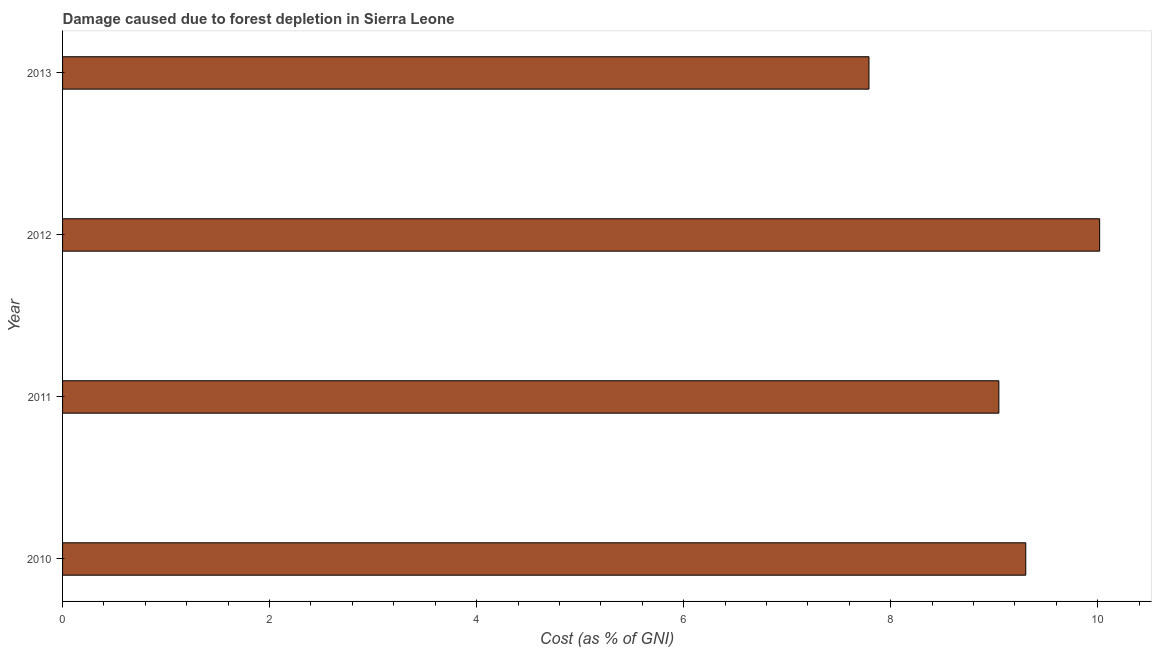Does the graph contain grids?
Offer a terse response. No. What is the title of the graph?
Offer a very short reply. Damage caused due to forest depletion in Sierra Leone. What is the label or title of the X-axis?
Your answer should be compact. Cost (as % of GNI). What is the damage caused due to forest depletion in 2013?
Keep it short and to the point. 7.79. Across all years, what is the maximum damage caused due to forest depletion?
Your answer should be compact. 10.02. Across all years, what is the minimum damage caused due to forest depletion?
Provide a succinct answer. 7.79. In which year was the damage caused due to forest depletion maximum?
Offer a terse response. 2012. What is the sum of the damage caused due to forest depletion?
Provide a succinct answer. 36.16. What is the difference between the damage caused due to forest depletion in 2010 and 2012?
Provide a short and direct response. -0.71. What is the average damage caused due to forest depletion per year?
Provide a short and direct response. 9.04. What is the median damage caused due to forest depletion?
Your answer should be compact. 9.18. What is the ratio of the damage caused due to forest depletion in 2010 to that in 2012?
Offer a terse response. 0.93. Is the damage caused due to forest depletion in 2012 less than that in 2013?
Provide a short and direct response. No. What is the difference between the highest and the second highest damage caused due to forest depletion?
Your answer should be compact. 0.71. Is the sum of the damage caused due to forest depletion in 2011 and 2013 greater than the maximum damage caused due to forest depletion across all years?
Provide a succinct answer. Yes. What is the difference between the highest and the lowest damage caused due to forest depletion?
Your response must be concise. 2.23. In how many years, is the damage caused due to forest depletion greater than the average damage caused due to forest depletion taken over all years?
Give a very brief answer. 3. Are all the bars in the graph horizontal?
Make the answer very short. Yes. How many years are there in the graph?
Your response must be concise. 4. Are the values on the major ticks of X-axis written in scientific E-notation?
Provide a short and direct response. No. What is the Cost (as % of GNI) of 2010?
Ensure brevity in your answer.  9.31. What is the Cost (as % of GNI) in 2011?
Provide a succinct answer. 9.05. What is the Cost (as % of GNI) of 2012?
Make the answer very short. 10.02. What is the Cost (as % of GNI) in 2013?
Make the answer very short. 7.79. What is the difference between the Cost (as % of GNI) in 2010 and 2011?
Your response must be concise. 0.26. What is the difference between the Cost (as % of GNI) in 2010 and 2012?
Keep it short and to the point. -0.71. What is the difference between the Cost (as % of GNI) in 2010 and 2013?
Ensure brevity in your answer.  1.51. What is the difference between the Cost (as % of GNI) in 2011 and 2012?
Keep it short and to the point. -0.97. What is the difference between the Cost (as % of GNI) in 2011 and 2013?
Give a very brief answer. 1.25. What is the difference between the Cost (as % of GNI) in 2012 and 2013?
Offer a very short reply. 2.23. What is the ratio of the Cost (as % of GNI) in 2010 to that in 2012?
Offer a very short reply. 0.93. What is the ratio of the Cost (as % of GNI) in 2010 to that in 2013?
Make the answer very short. 1.19. What is the ratio of the Cost (as % of GNI) in 2011 to that in 2012?
Make the answer very short. 0.9. What is the ratio of the Cost (as % of GNI) in 2011 to that in 2013?
Offer a terse response. 1.16. What is the ratio of the Cost (as % of GNI) in 2012 to that in 2013?
Provide a short and direct response. 1.29. 